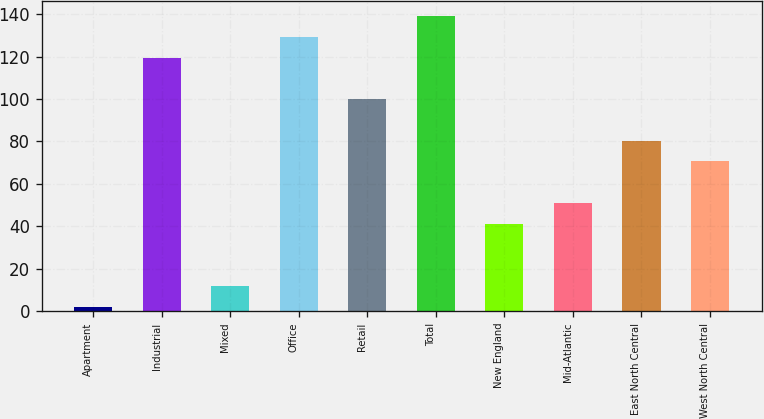Convert chart to OTSL. <chart><loc_0><loc_0><loc_500><loc_500><bar_chart><fcel>Apartment<fcel>Industrial<fcel>Mixed<fcel>Office<fcel>Retail<fcel>Total<fcel>New England<fcel>Mid-Atlantic<fcel>East North Central<fcel>West North Central<nl><fcel>2<fcel>119.6<fcel>11.8<fcel>129.4<fcel>100<fcel>139.2<fcel>41.2<fcel>51<fcel>80.4<fcel>70.6<nl></chart> 